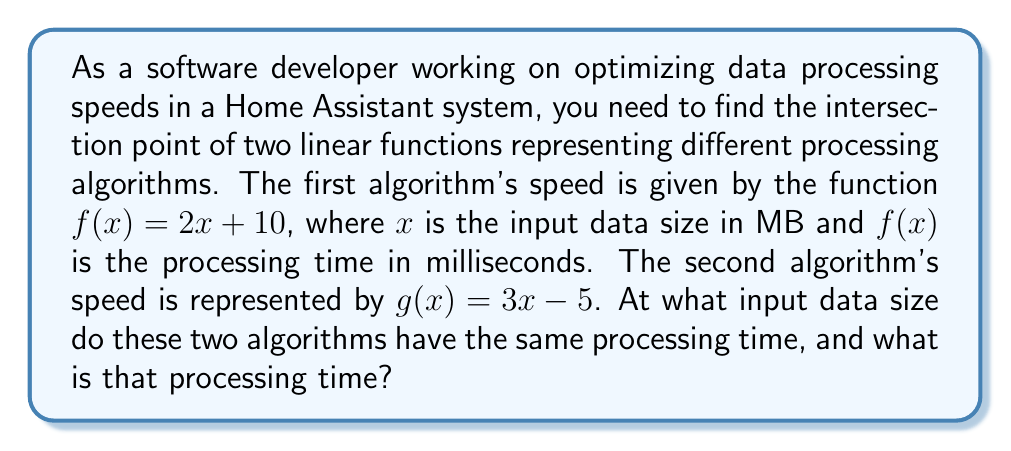Can you answer this question? To solve this problem, we need to find the point of intersection between the two linear functions. This can be done by setting the functions equal to each other and solving for $x$.

1. Set the functions equal:
   $$2x + 10 = 3x - 5$$

2. Subtract $2x$ from both sides:
   $$10 = x - 5$$

3. Add 5 to both sides:
   $$15 = x$$

4. Now that we have the $x$ value (input data size), we can substitute it into either function to find the $y$ value (processing time):

   Using $f(x)$:
   $$f(15) = 2(15) + 10 = 30 + 10 = 40$$

   Or using $g(x)$:
   $$g(15) = 3(15) - 5 = 45 - 5 = 40$$

Both functions give the same result, confirming our solution.

In the context of Python and Home Assistant, you could verify this result programmatically:

```python
def f(x):
    return 2*x + 10

def g(x):
    return 3*x - 5

x = 15
print(f"At x = {x}, f(x) = {f(x)} and g(x) = {g(x)}")
```

This would output: "At x = 15, f(x) = 40 and g(x) = 40"
Answer: The two algorithms have the same processing time when the input data size is 15 MB, and the processing time at this point is 40 milliseconds. 